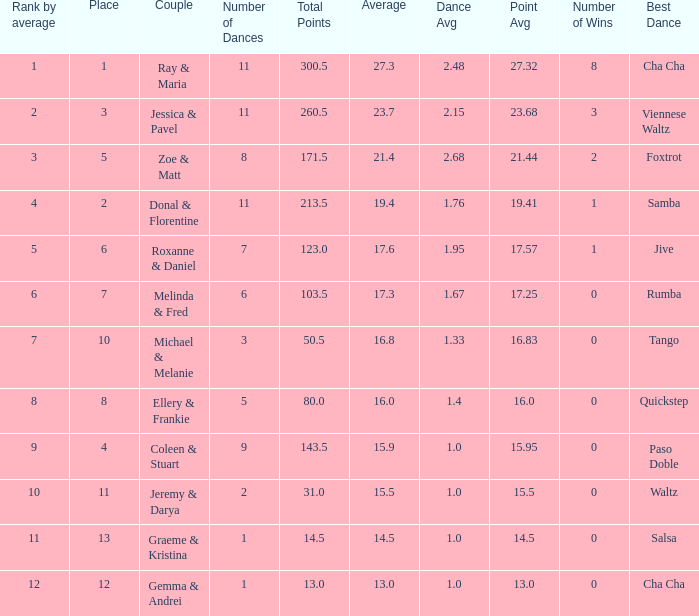If the total points is 50.5, what is the total number of dances? 1.0. 